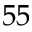Convert formula to latex. <formula><loc_0><loc_0><loc_500><loc_500>5 5</formula> 